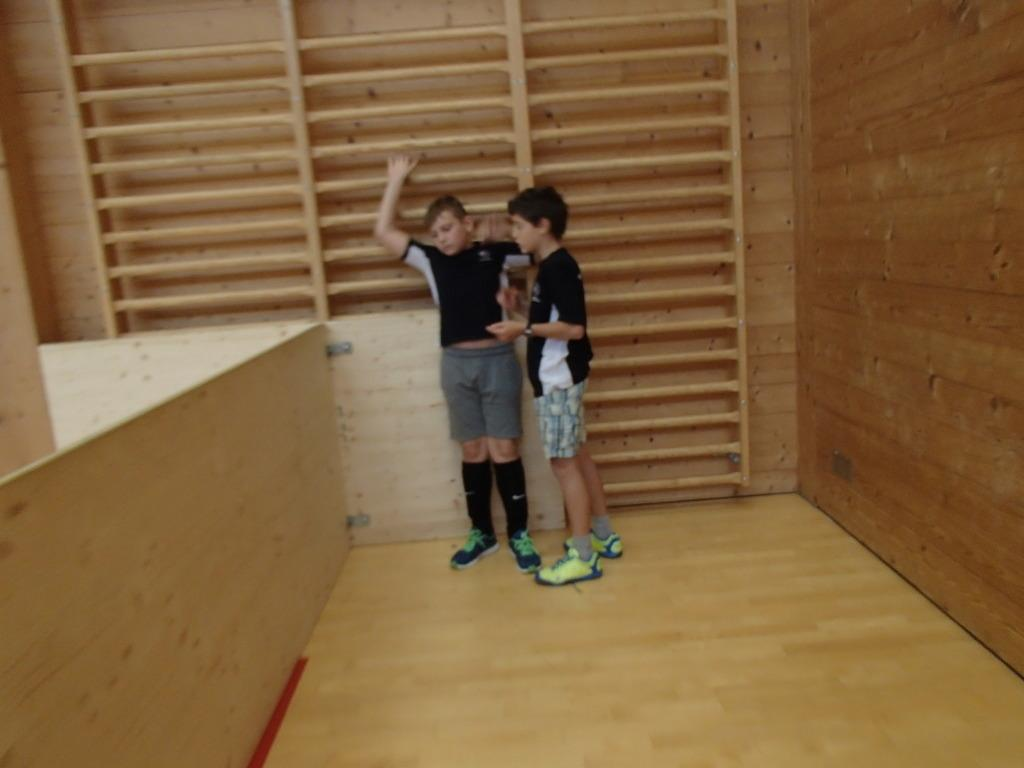How many people are in the image? There are two boys in the image. Where are the boys located in the image? The boys are standing in the center of the image. What can be seen in the background of the image? There is a wall in the background of the image. What is at the bottom of the image? The floor is present at the bottom of the image. What type of star can be seen shining brightly in the image? There is no star visible in the image. What kind of farm animals can be seen grazing in the background of the image? There is no farm or animals present in the image; it features two boys standing in front of a wall. 